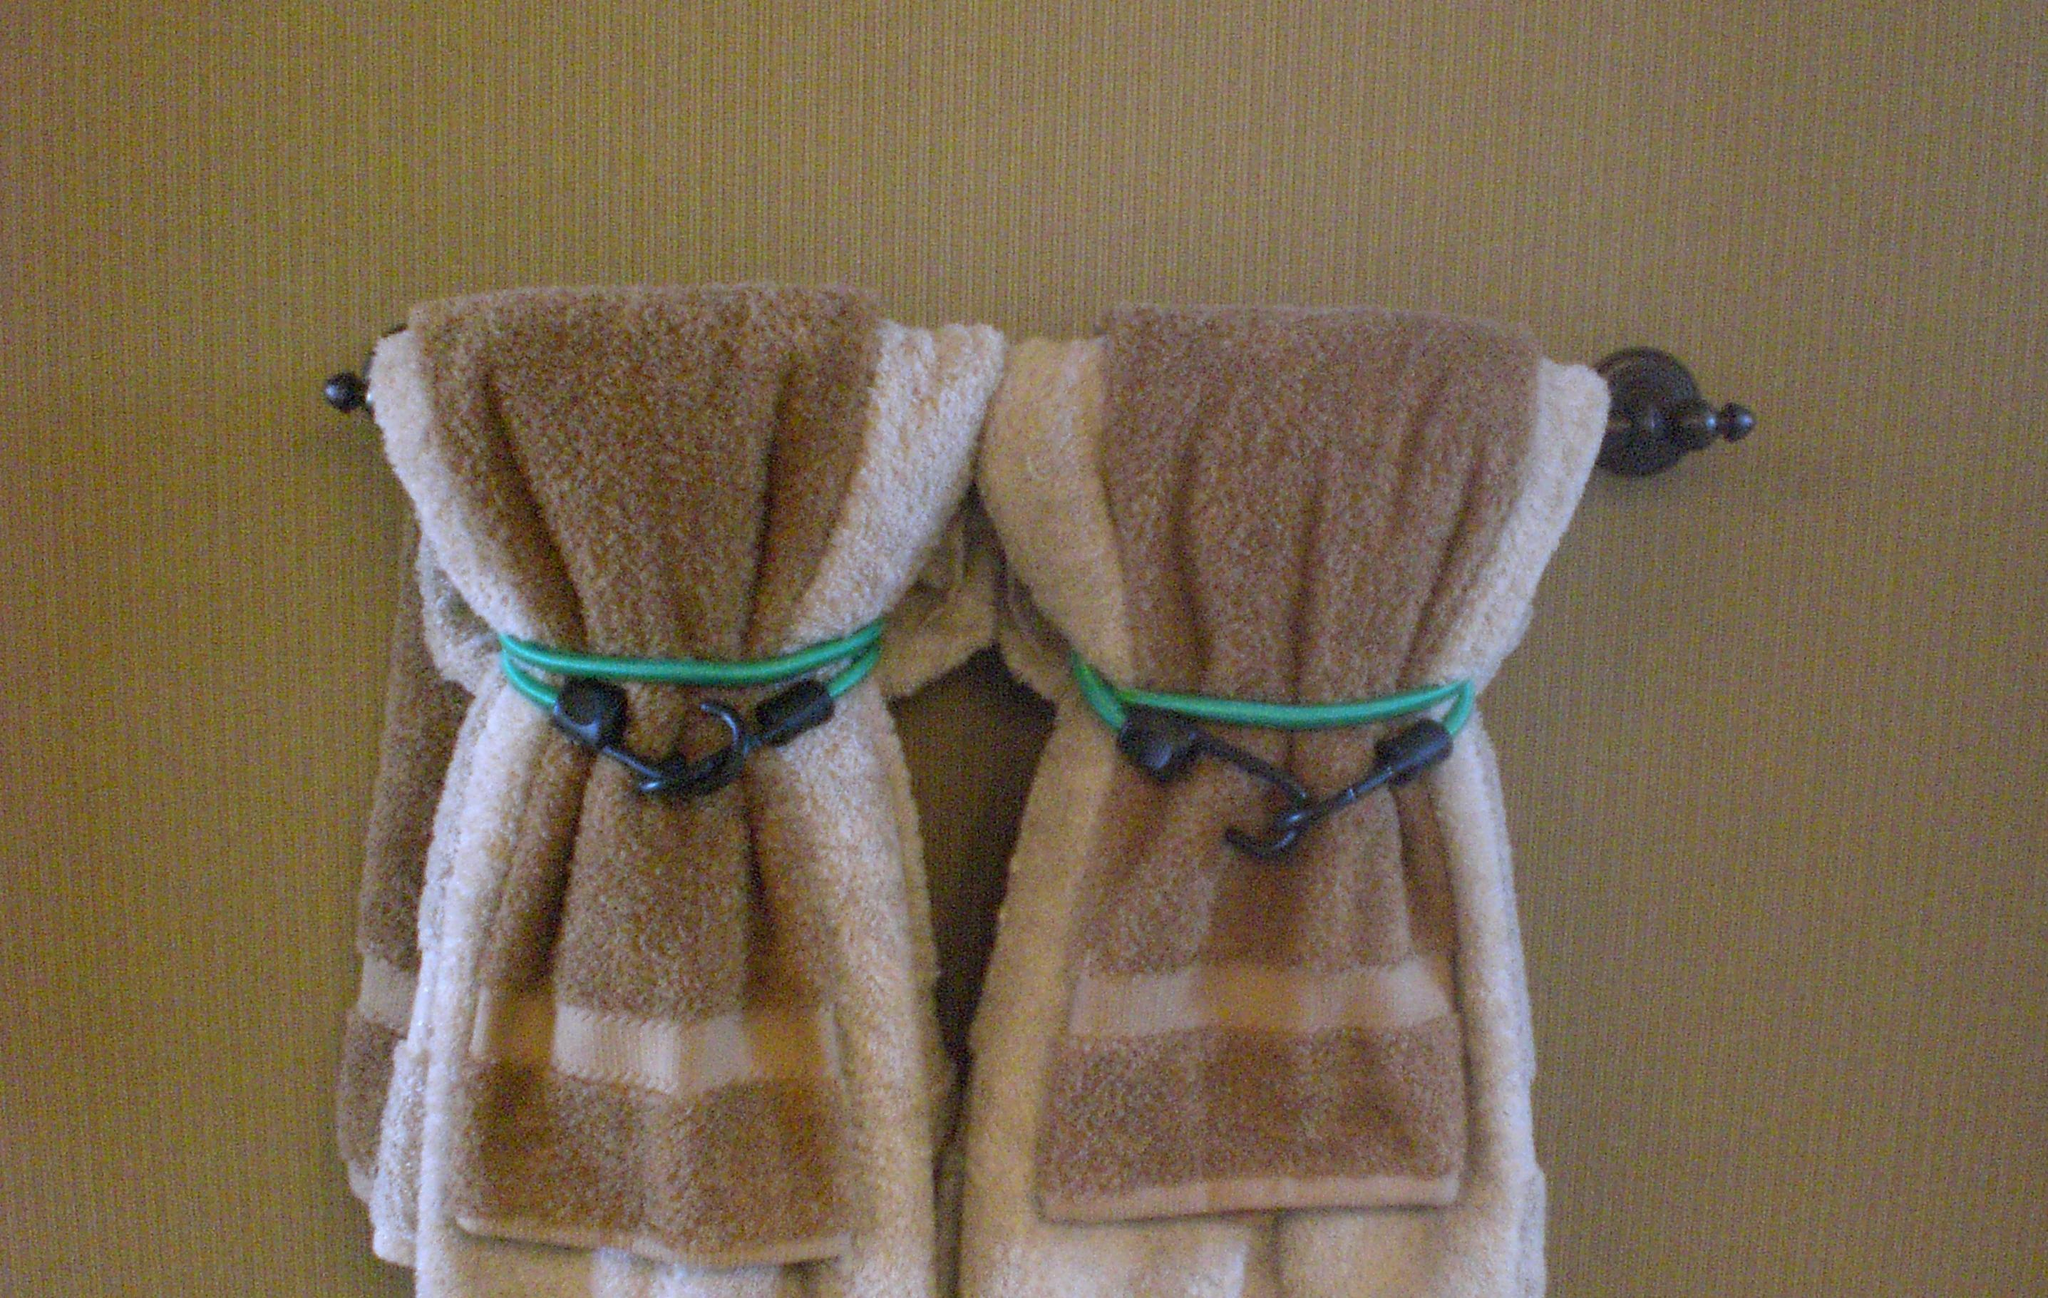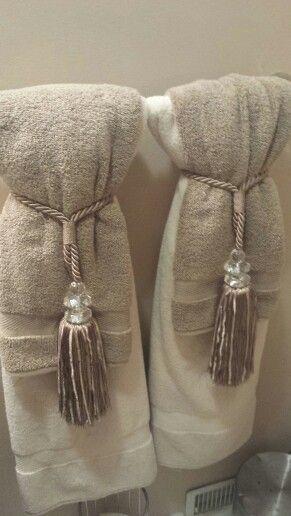The first image is the image on the left, the second image is the image on the right. For the images displayed, is the sentence "The left and right image contains the same number of rows of tie towels." factually correct? Answer yes or no. Yes. 